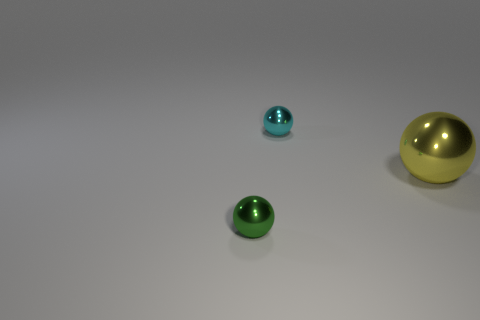Subtract all small balls. How many balls are left? 1 Add 3 big shiny balls. How many objects exist? 6 Subtract all purple spheres. Subtract all red cylinders. How many spheres are left? 3 Add 2 green metallic things. How many green metallic things exist? 3 Subtract 1 yellow spheres. How many objects are left? 2 Subtract all small gray balls. Subtract all green metallic balls. How many objects are left? 2 Add 2 big yellow objects. How many big yellow objects are left? 3 